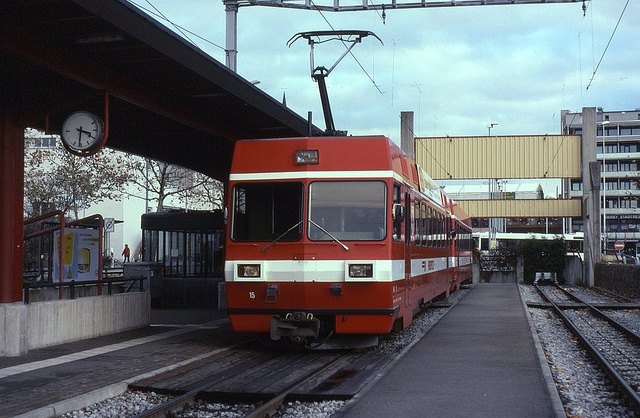Describe the objects in this image and their specific colors. I can see train in black, maroon, gray, and beige tones, clock in black and gray tones, and people in black, gray, maroon, and darkgray tones in this image. 